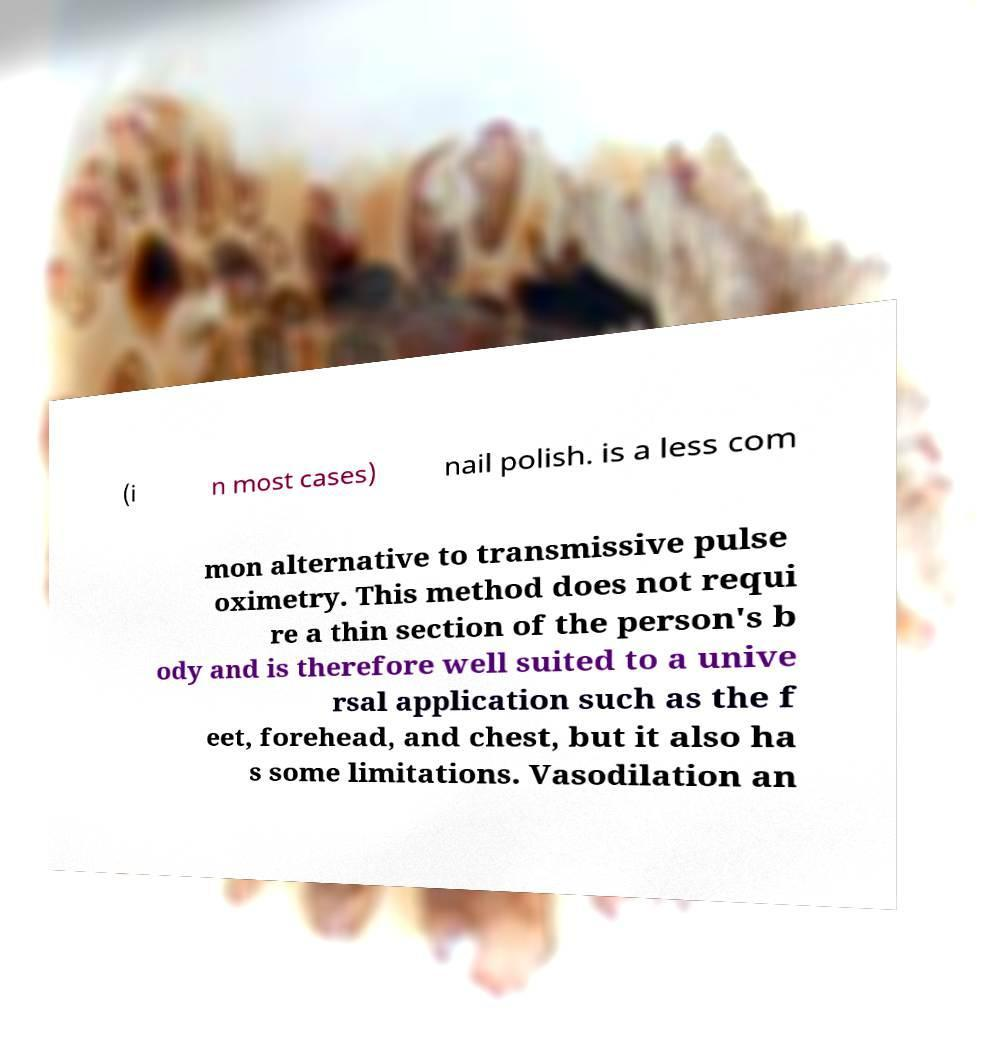What messages or text are displayed in this image? I need them in a readable, typed format. (i n most cases) nail polish. is a less com mon alternative to transmissive pulse oximetry. This method does not requi re a thin section of the person's b ody and is therefore well suited to a unive rsal application such as the f eet, forehead, and chest, but it also ha s some limitations. Vasodilation an 